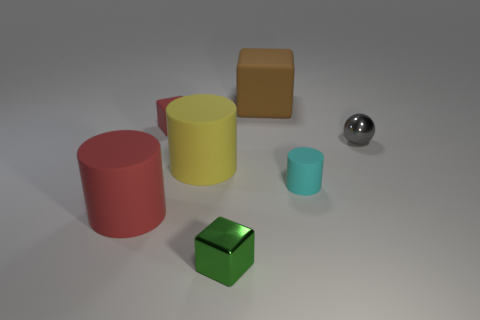What are the different shapes we can see in the image? There are several shapes present: we can see two cylinders, a sphere, and two cubes. The cylinders have different heights, the sphere is perfectly round, and the cubes display equal-length edges. What colors are the objects? The objects have varied colors: one cylinder is red, the other yellow, there's a green cube, a brown cube, and a silver sphere. 